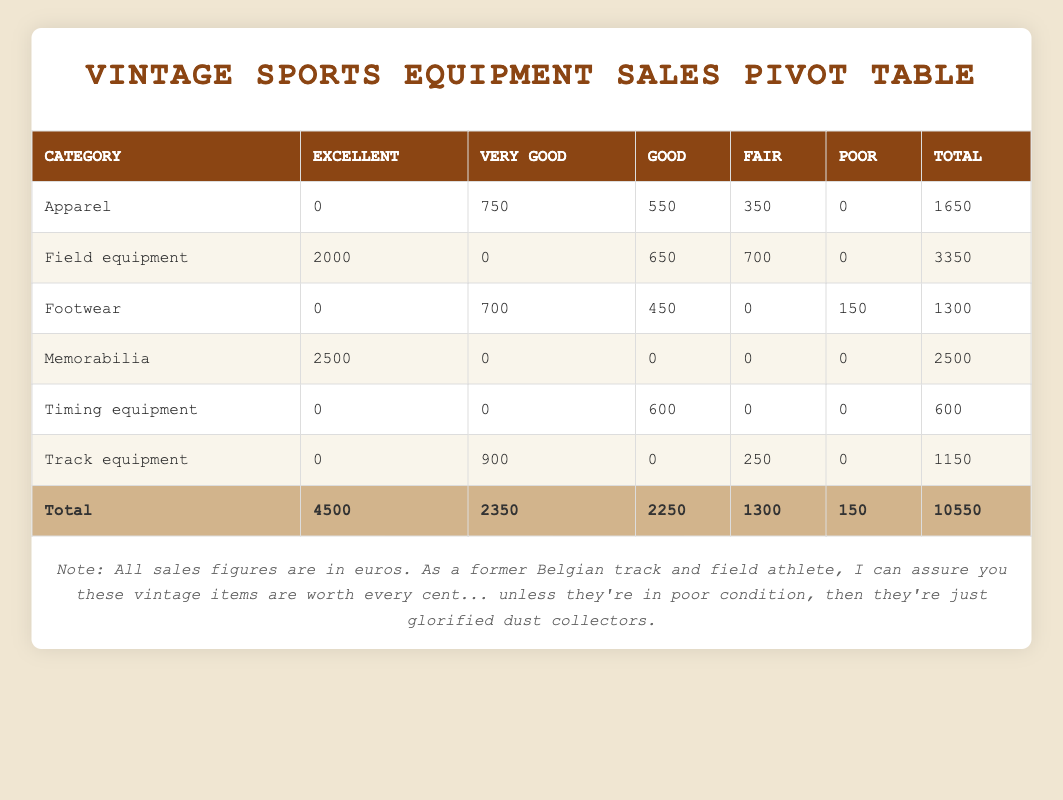What item category had the highest total sales? To find the highest total sales, we look at the "Total" column in the last row. The category "Field equipment" has a total of 3350 euros, which is higher than any other category.
Answer: Field equipment How many items in the 'Apparel' category are rated as 'Fair'? Checking the "Apparel" row, there is one item listed with a "Fair" condition, which is the 1970s Belgian national team warm-up jacket, accounting for 350 euros in sales.
Answer: 1 What is the total sales value for items rated as 'Excellent'? Summing the sales for all categories with 'Excellent' condition: 2000 (Field equipment) + 2500 (Memorabilia) + 0 (Apparel) + 0 (Footwear) + 0 (Timing equipment) + 0 (Track equipment) = 4500 euros.
Answer: 4500 Is there any item that has a 'Poor' condition in the 'Timing equipment' category? Looking under the "Timing equipment" category, the total sales for 'Poor' condition is 0, meaning there are no items listed there in that condition.
Answer: No What is the difference in total sales between the 'Very good' and 'Fair' condition ratings? First, sum the total sales for 'Very good' condition: 750 (Apparel) + 0 (Field equipment) + 700 (Footwear) + 0 (Memorabilia) + 0 (Timing equipment) + 900 (Track equipment) = 2350 euros. Then, for 'Fair': 350 (Apparel) + 700 (Field equipment) + 0 (Footwear) + 0 (Memorabilia) + 0 (Timing equipment) + 250 (Track equipment) = 1300 euros. The difference is 2350 - 1300 = 1050 euros.
Answer: 1050 What is the combined total sales of all 'Footwear' items? To find the total sales for 'Footwear', sum the sales: 0 (Excellent) + 700 (Very good) + 450 (Good) + 0 (Fair) + 150 (Poor) = 1300 euros.
Answer: 1300 